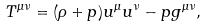Convert formula to latex. <formula><loc_0><loc_0><loc_500><loc_500>T ^ { \mu \nu } = ( \rho + p ) u ^ { \mu } u ^ { \nu } - p g ^ { \mu \nu } ,</formula> 